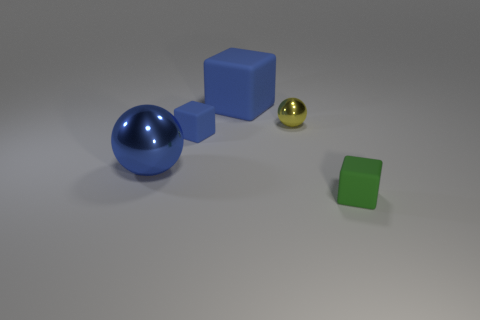Is there any significance to the arrangement of the objects? The arrangement seems deliberate, with the objects placed at varying distances from one another, possibly to either showcase their distinct colors and shapes or to create a visually pleasing composition. Without additional context, it's difficult to determine a specific significance beyond an artistic or display purpose. 